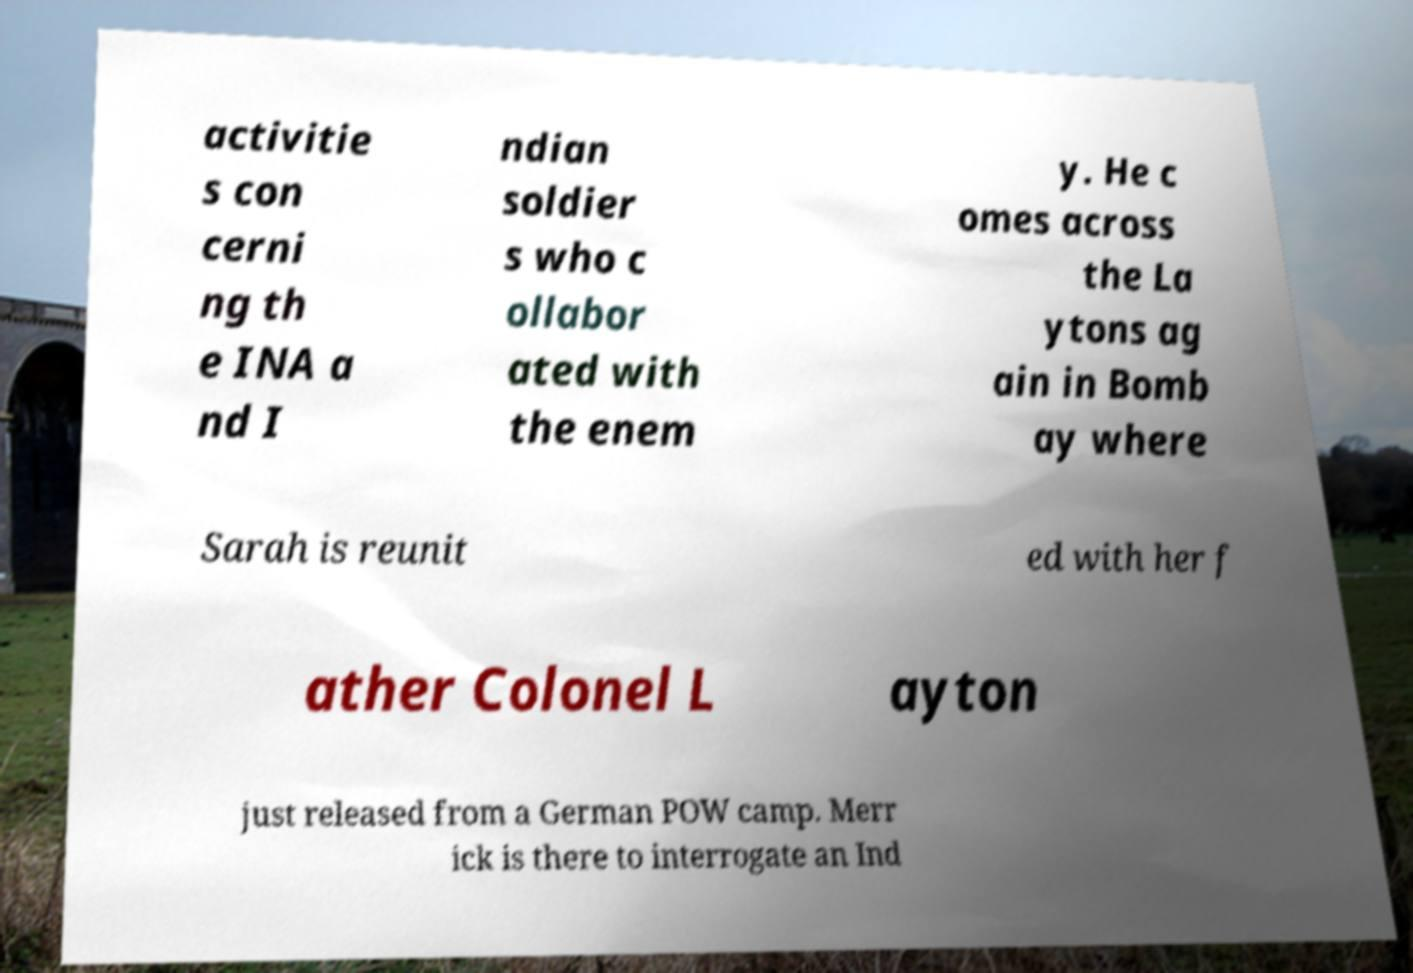Please read and relay the text visible in this image. What does it say? activitie s con cerni ng th e INA a nd I ndian soldier s who c ollabor ated with the enem y. He c omes across the La ytons ag ain in Bomb ay where Sarah is reunit ed with her f ather Colonel L ayton just released from a German POW camp. Merr ick is there to interrogate an Ind 